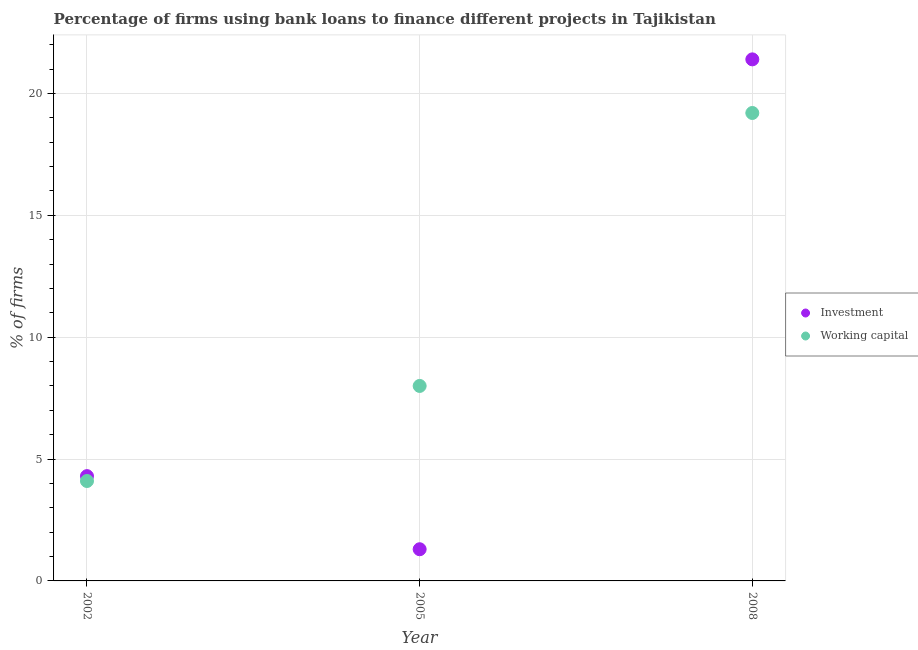How many different coloured dotlines are there?
Provide a succinct answer. 2. What is the percentage of firms using banks to finance investment in 2008?
Provide a short and direct response. 21.4. Across all years, what is the maximum percentage of firms using banks to finance investment?
Ensure brevity in your answer.  21.4. What is the total percentage of firms using banks to finance working capital in the graph?
Give a very brief answer. 31.3. What is the difference between the percentage of firms using banks to finance working capital in 2002 and that in 2005?
Make the answer very short. -3.9. What is the difference between the percentage of firms using banks to finance investment in 2002 and the percentage of firms using banks to finance working capital in 2008?
Your response must be concise. -14.9. In the year 2002, what is the difference between the percentage of firms using banks to finance working capital and percentage of firms using banks to finance investment?
Offer a terse response. -0.2. What is the ratio of the percentage of firms using banks to finance investment in 2002 to that in 2008?
Ensure brevity in your answer.  0.2. Is the percentage of firms using banks to finance working capital in 2002 less than that in 2008?
Provide a short and direct response. Yes. Is the difference between the percentage of firms using banks to finance working capital in 2002 and 2005 greater than the difference between the percentage of firms using banks to finance investment in 2002 and 2005?
Provide a short and direct response. No. What is the difference between the highest and the lowest percentage of firms using banks to finance investment?
Provide a short and direct response. 20.1. Is the sum of the percentage of firms using banks to finance working capital in 2002 and 2005 greater than the maximum percentage of firms using banks to finance investment across all years?
Keep it short and to the point. No. Does the percentage of firms using banks to finance investment monotonically increase over the years?
Give a very brief answer. No. Is the percentage of firms using banks to finance working capital strictly less than the percentage of firms using banks to finance investment over the years?
Keep it short and to the point. No. How many dotlines are there?
Keep it short and to the point. 2. How many years are there in the graph?
Provide a succinct answer. 3. Are the values on the major ticks of Y-axis written in scientific E-notation?
Provide a succinct answer. No. What is the title of the graph?
Give a very brief answer. Percentage of firms using bank loans to finance different projects in Tajikistan. Does "Frequency of shipment arrival" appear as one of the legend labels in the graph?
Provide a succinct answer. No. What is the label or title of the X-axis?
Give a very brief answer. Year. What is the label or title of the Y-axis?
Provide a succinct answer. % of firms. What is the % of firms in Investment in 2002?
Your response must be concise. 4.3. What is the % of firms in Working capital in 2002?
Make the answer very short. 4.1. What is the % of firms of Investment in 2005?
Your answer should be very brief. 1.3. What is the % of firms of Investment in 2008?
Your response must be concise. 21.4. What is the % of firms in Working capital in 2008?
Keep it short and to the point. 19.2. Across all years, what is the maximum % of firms in Investment?
Keep it short and to the point. 21.4. Across all years, what is the minimum % of firms of Working capital?
Your response must be concise. 4.1. What is the total % of firms of Investment in the graph?
Your response must be concise. 27. What is the total % of firms of Working capital in the graph?
Your response must be concise. 31.3. What is the difference between the % of firms of Working capital in 2002 and that in 2005?
Offer a terse response. -3.9. What is the difference between the % of firms in Investment in 2002 and that in 2008?
Provide a succinct answer. -17.1. What is the difference between the % of firms in Working capital in 2002 and that in 2008?
Provide a short and direct response. -15.1. What is the difference between the % of firms of Investment in 2005 and that in 2008?
Your answer should be very brief. -20.1. What is the difference between the % of firms in Working capital in 2005 and that in 2008?
Offer a very short reply. -11.2. What is the difference between the % of firms of Investment in 2002 and the % of firms of Working capital in 2008?
Offer a very short reply. -14.9. What is the difference between the % of firms in Investment in 2005 and the % of firms in Working capital in 2008?
Your response must be concise. -17.9. What is the average % of firms in Investment per year?
Ensure brevity in your answer.  9. What is the average % of firms in Working capital per year?
Keep it short and to the point. 10.43. In the year 2005, what is the difference between the % of firms of Investment and % of firms of Working capital?
Your answer should be compact. -6.7. What is the ratio of the % of firms of Investment in 2002 to that in 2005?
Keep it short and to the point. 3.31. What is the ratio of the % of firms in Working capital in 2002 to that in 2005?
Provide a short and direct response. 0.51. What is the ratio of the % of firms in Investment in 2002 to that in 2008?
Provide a succinct answer. 0.2. What is the ratio of the % of firms of Working capital in 2002 to that in 2008?
Make the answer very short. 0.21. What is the ratio of the % of firms of Investment in 2005 to that in 2008?
Ensure brevity in your answer.  0.06. What is the ratio of the % of firms in Working capital in 2005 to that in 2008?
Your answer should be very brief. 0.42. What is the difference between the highest and the second highest % of firms of Investment?
Your answer should be very brief. 17.1. What is the difference between the highest and the lowest % of firms of Investment?
Make the answer very short. 20.1. What is the difference between the highest and the lowest % of firms of Working capital?
Provide a short and direct response. 15.1. 